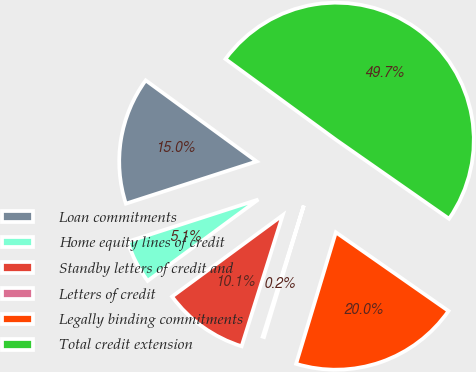Convert chart. <chart><loc_0><loc_0><loc_500><loc_500><pie_chart><fcel>Loan commitments<fcel>Home equity lines of credit<fcel>Standby letters of credit and<fcel>Letters of credit<fcel>Legally binding commitments<fcel>Total credit extension<nl><fcel>15.02%<fcel>5.12%<fcel>10.07%<fcel>0.17%<fcel>19.97%<fcel>49.66%<nl></chart> 